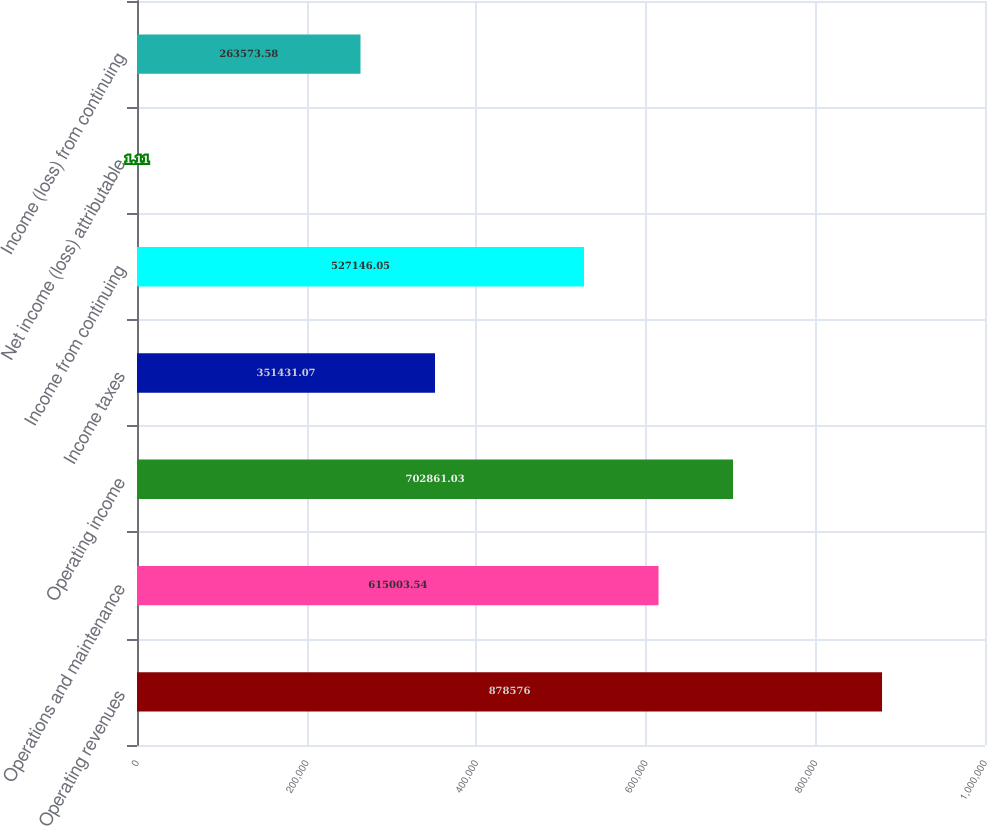<chart> <loc_0><loc_0><loc_500><loc_500><bar_chart><fcel>Operating revenues<fcel>Operations and maintenance<fcel>Operating income<fcel>Income taxes<fcel>Income from continuing<fcel>Net income (loss) attributable<fcel>Income (loss) from continuing<nl><fcel>878576<fcel>615004<fcel>702861<fcel>351431<fcel>527146<fcel>1.11<fcel>263574<nl></chart> 